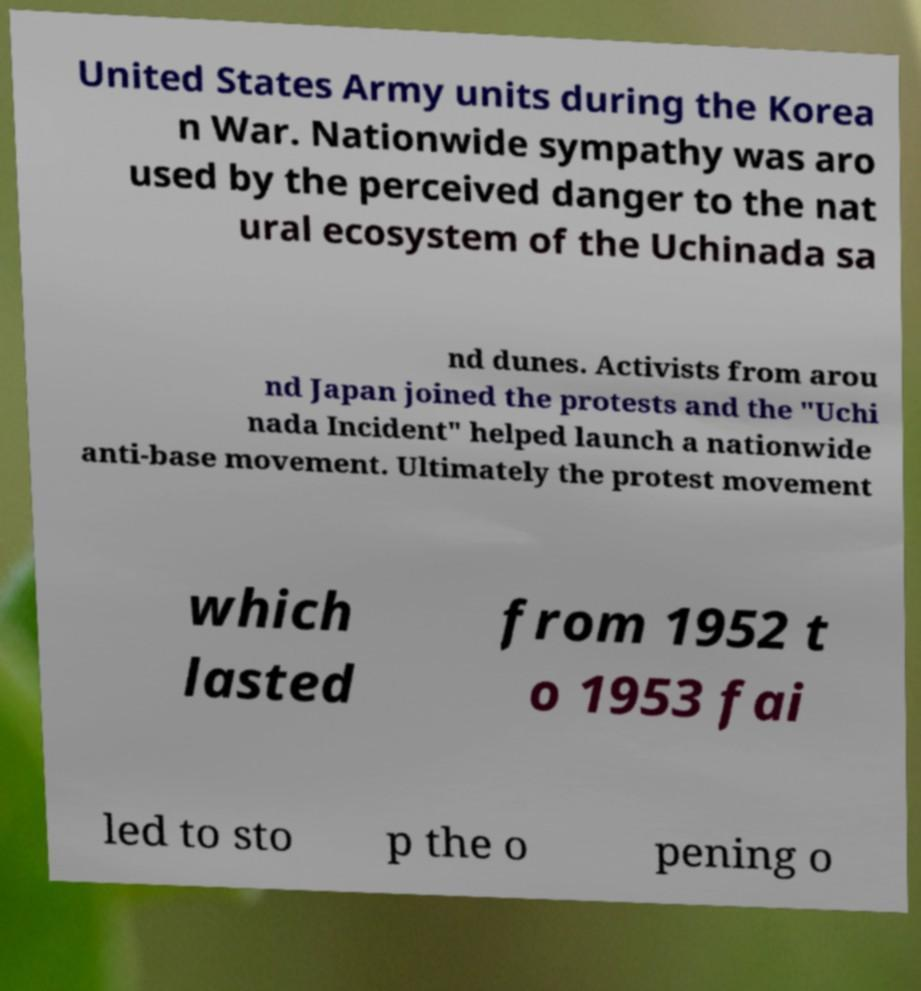Please identify and transcribe the text found in this image. United States Army units during the Korea n War. Nationwide sympathy was aro used by the perceived danger to the nat ural ecosystem of the Uchinada sa nd dunes. Activists from arou nd Japan joined the protests and the "Uchi nada Incident" helped launch a nationwide anti-base movement. Ultimately the protest movement which lasted from 1952 t o 1953 fai led to sto p the o pening o 